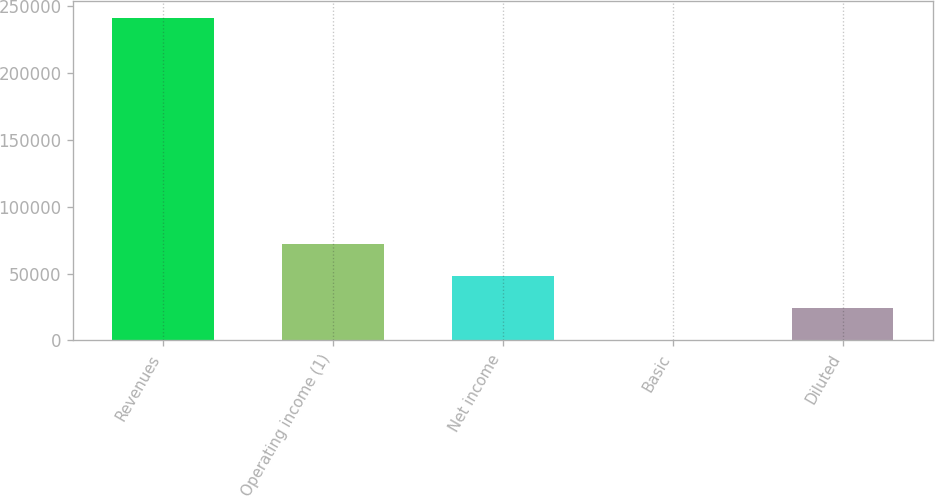Convert chart. <chart><loc_0><loc_0><loc_500><loc_500><bar_chart><fcel>Revenues<fcel>Operating income (1)<fcel>Net income<fcel>Basic<fcel>Diluted<nl><fcel>241360<fcel>72408.1<fcel>48272.1<fcel>0.08<fcel>24136.1<nl></chart> 